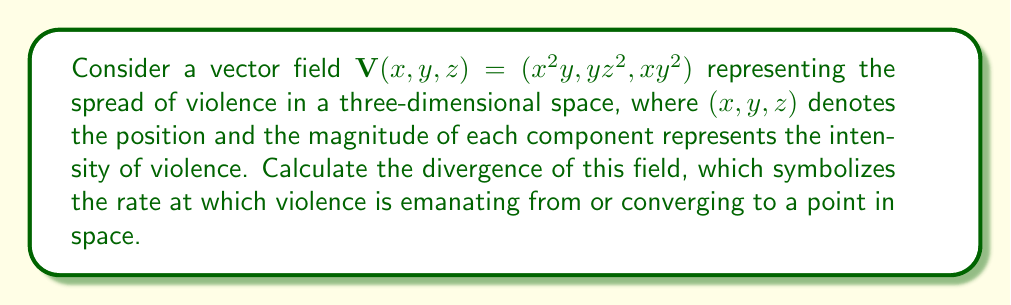Can you answer this question? To determine the divergence of the vector field $\mathbf{V}(x,y,z) = (x^2y, yz^2, xy^2)$, we need to calculate the sum of the partial derivatives of each component with respect to its corresponding variable. The divergence is given by:

$$\nabla \cdot \mathbf{V} = \frac{\partial V_x}{\partial x} + \frac{\partial V_y}{\partial y} + \frac{\partial V_z}{\partial z}$$

Let's calculate each partial derivative:

1. $\frac{\partial V_x}{\partial x}$:
   $V_x = x^2y$, so $\frac{\partial V_x}{\partial x} = 2xy$

2. $\frac{\partial V_y}{\partial y}$:
   $V_y = yz^2$, so $\frac{\partial V_y}{\partial y} = z^2$

3. $\frac{\partial V_z}{\partial z}$:
   $V_z = xy^2$, so $\frac{\partial V_z}{\partial z} = 0$

Now, we sum these partial derivatives:

$$\nabla \cdot \mathbf{V} = \frac{\partial V_x}{\partial x} + \frac{\partial V_y}{\partial y} + \frac{\partial V_z}{\partial z}$$
$$\nabla \cdot \mathbf{V} = 2xy + z^2 + 0$$
$$\nabla \cdot \mathbf{V} = 2xy + z^2$$

This result represents the rate at which violence is spreading (positive divergence) or converging (negative divergence) at any point $(x,y,z)$ in the space.
Answer: $2xy + z^2$ 